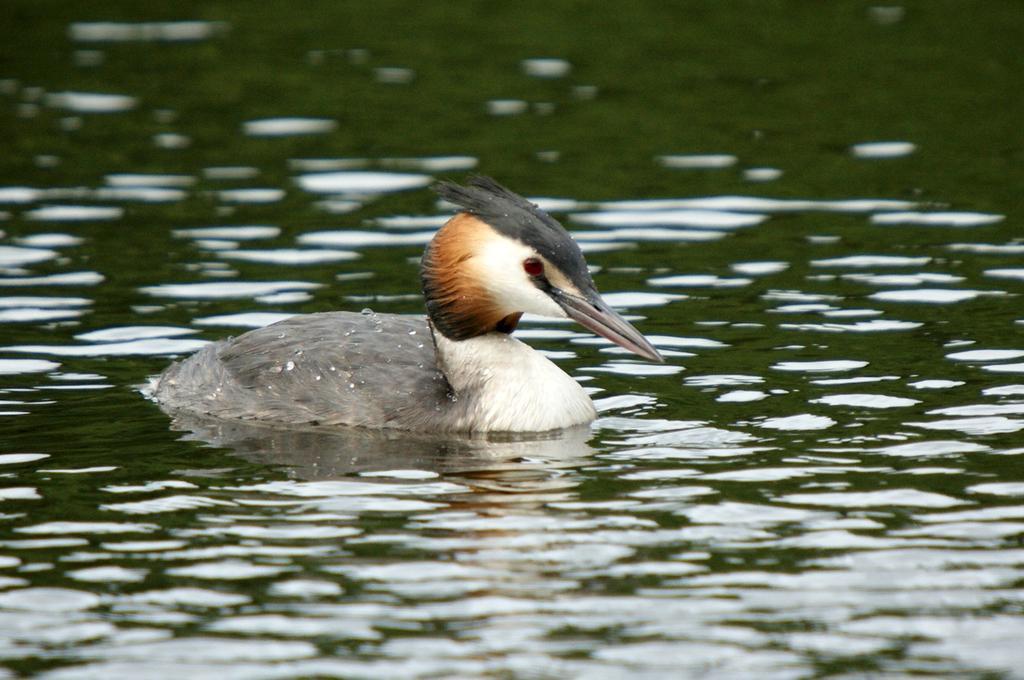Could you give a brief overview of what you see in this image? It is a duck which is swimming in the water. 